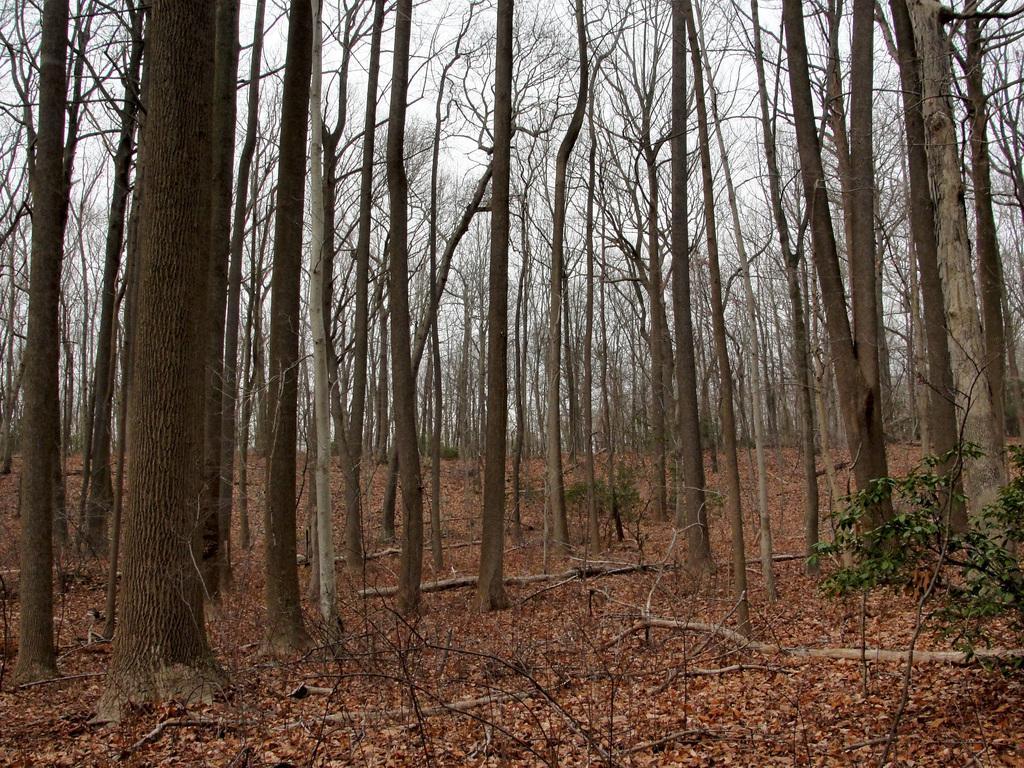Describe this image in one or two sentences. In this image I can see at the bottom there are dried leaves, in the middle there are very big trees. At the top it is the sky. 